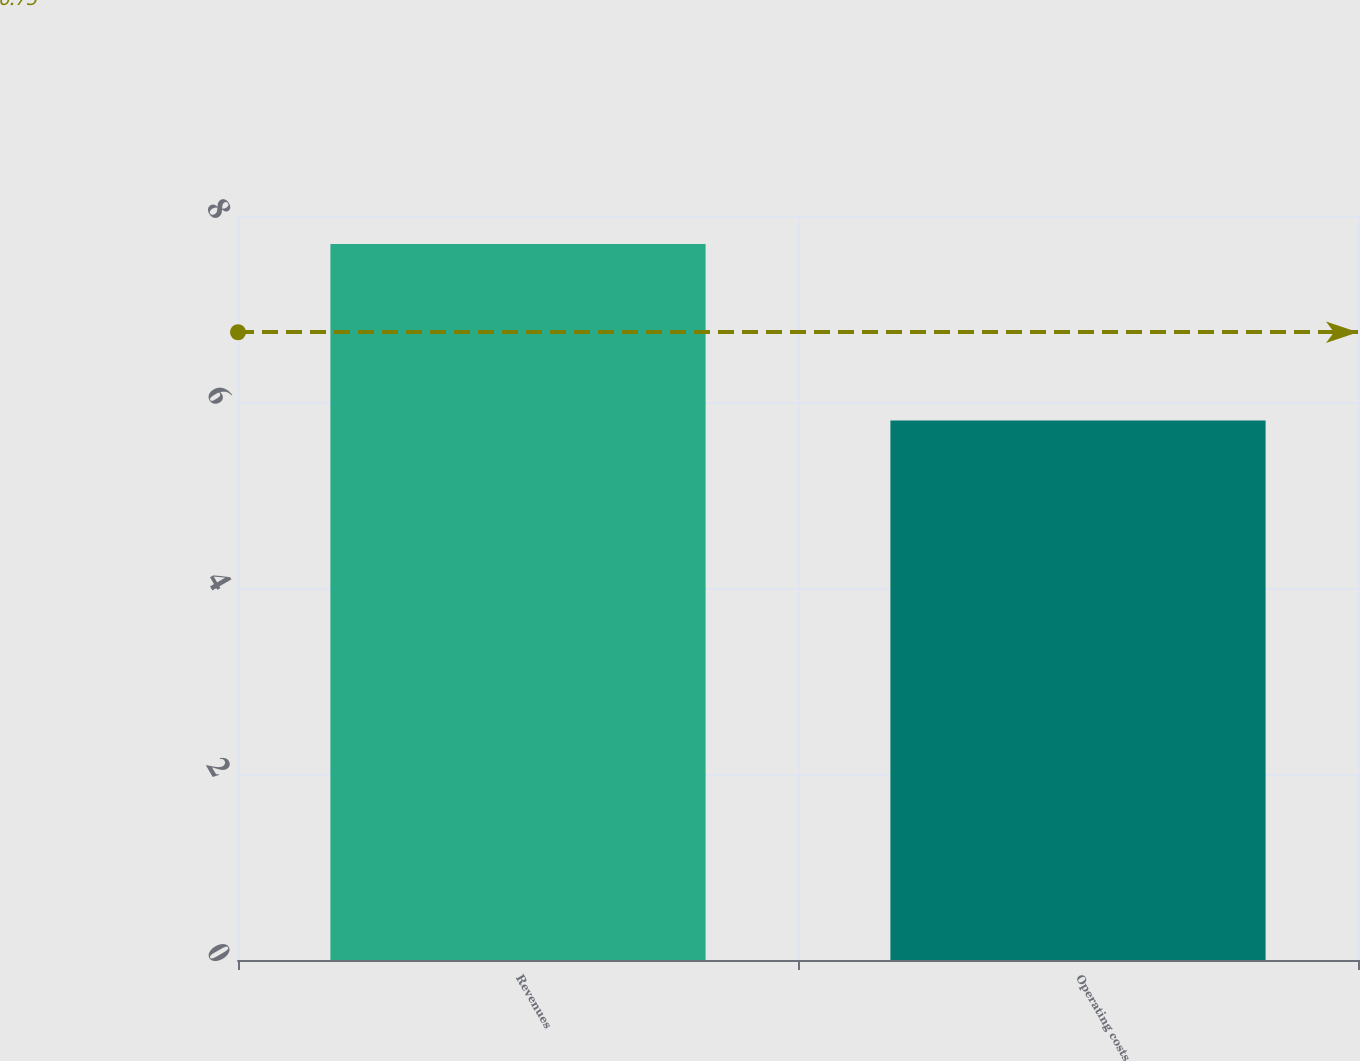Convert chart. <chart><loc_0><loc_0><loc_500><loc_500><bar_chart><fcel>Revenues<fcel>Operating costs<nl><fcel>7.7<fcel>5.8<nl></chart> 